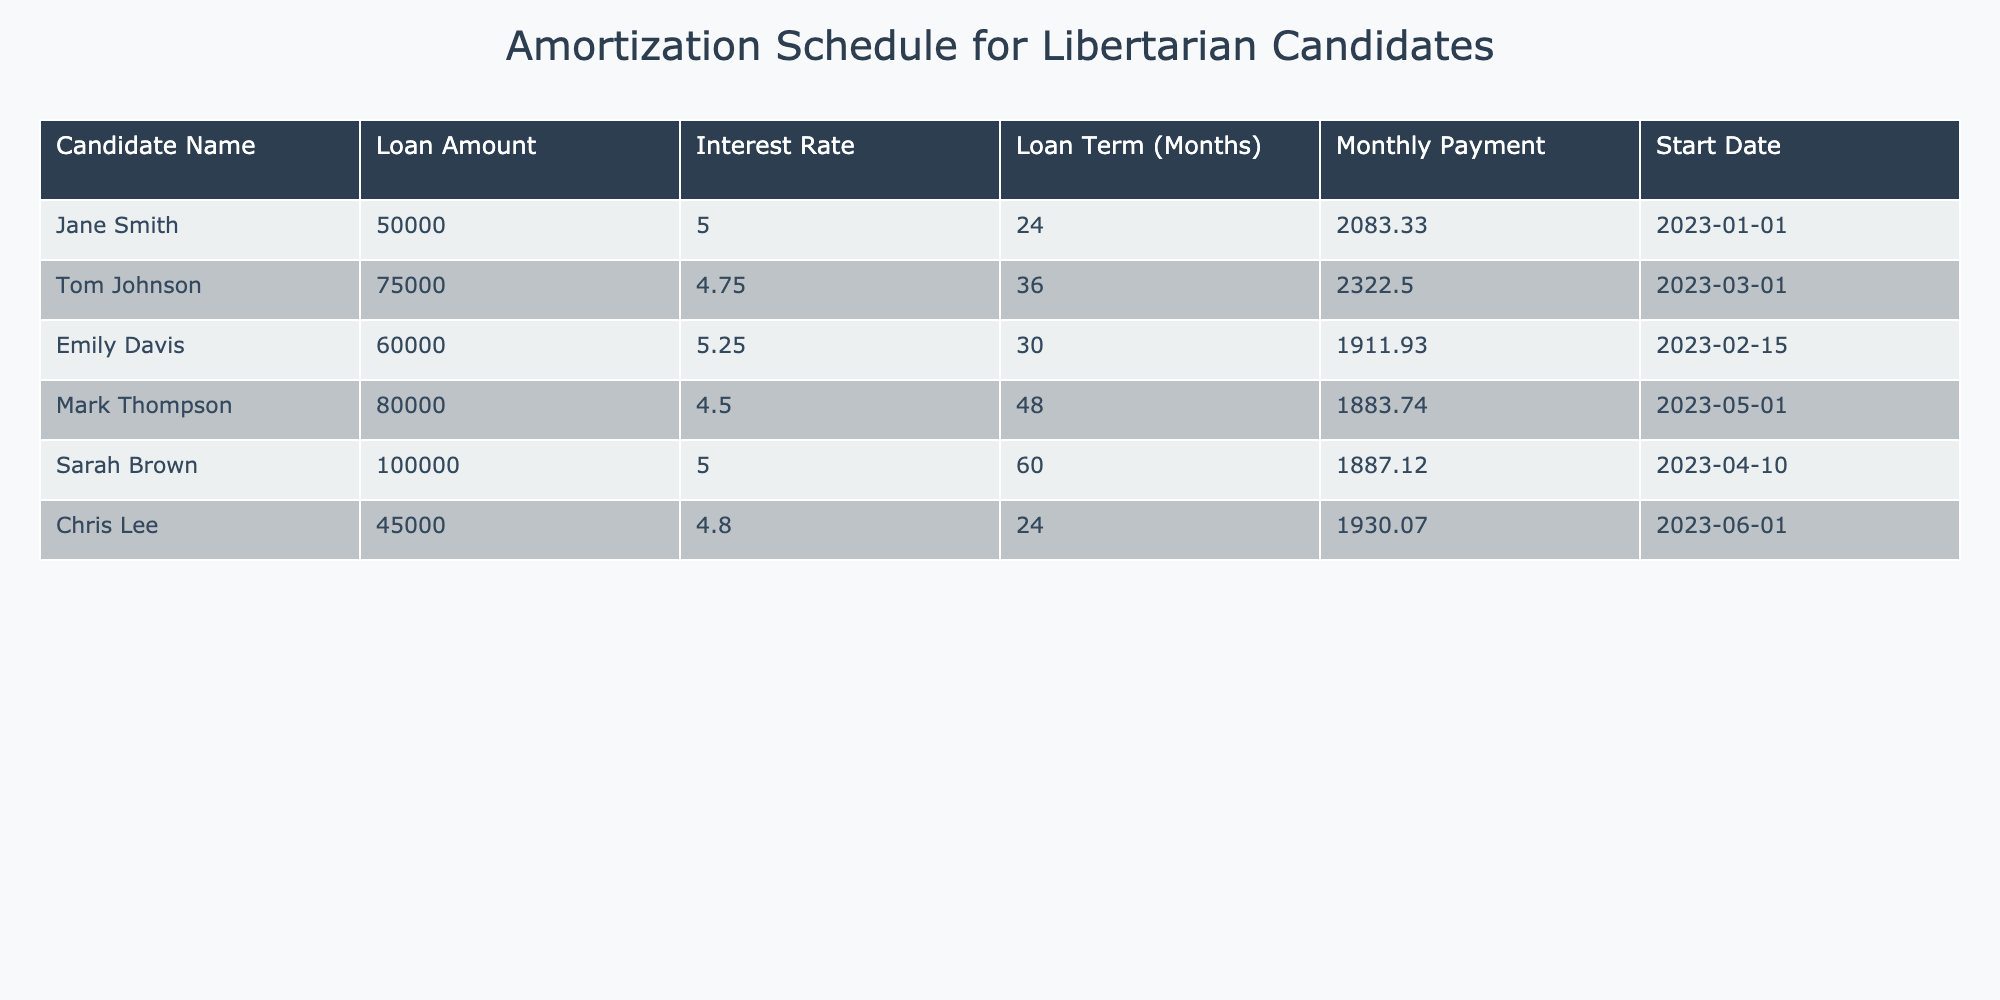What is the loan amount for Sarah Brown? The loan amount for Sarah Brown can be found in the "Loan Amount" column corresponding to her name in the table. The value is listed as 100000.
Answer: 100000 What is the monthly payment for Mark Thompson? To find out the monthly payment for Mark Thompson, we can look at the "Monthly Payment" column in the row where his name appears. The amount listed is 1883.74.
Answer: 1883.74 Which candidate has the longest loan term and what is that term? By examining the "Loan Term (Months)" column, Mark Thompson has the longest loan term listed as 48 months, compared to other candidates.
Answer: 48 What is the total loan amount taken out by the candidates? To calculate the total loan amount, we sum the loan amounts from the "Loan Amount" column: 50000 + 75000 + 60000 + 80000 + 100000 + 45000 = 395000.
Answer: 395000 Is Jane Smith's interest rate higher than the average interest rate of all candidates? First, we must calculate the average interest rate by summing all interest rates (5.00 + 4.75 + 5.25 + 4.50 + 5.00 + 4.80) = 29.30, then divide by 6, resulting in approximately 4.88. Since Jane's rate is 5.00, it is higher.
Answer: Yes What is the difference in loan amounts between Tom Johnson and Chris Lee? The loan amount for Tom Johnson is 75000 and for Chris Lee it is 45000. The difference is calculated as 75000 - 45000 = 30000.
Answer: 30000 Which candidates have a monthly payment greater than 2000? To determine this, we look at the "Monthly Payment" column and see that both Jane Smith (2083.33) and Tom Johnson (2322.50) have payments greater than 2000.
Answer: Jane Smith, Tom Johnson What is the average monthly payment for all candidates? We sum all the monthly payments (2083.33 + 2322.50 + 1911.93 + 1883.74 + 1887.12 + 1930.07) = 11918.69, and divide by 6 to find the average: 11918.69 / 6 = 1986.45.
Answer: 1986.45 Are there any candidates with a loan amount less than 50000? Reviewing the "Loan Amount" column shows no candidates have amounts less than 50000.
Answer: No 